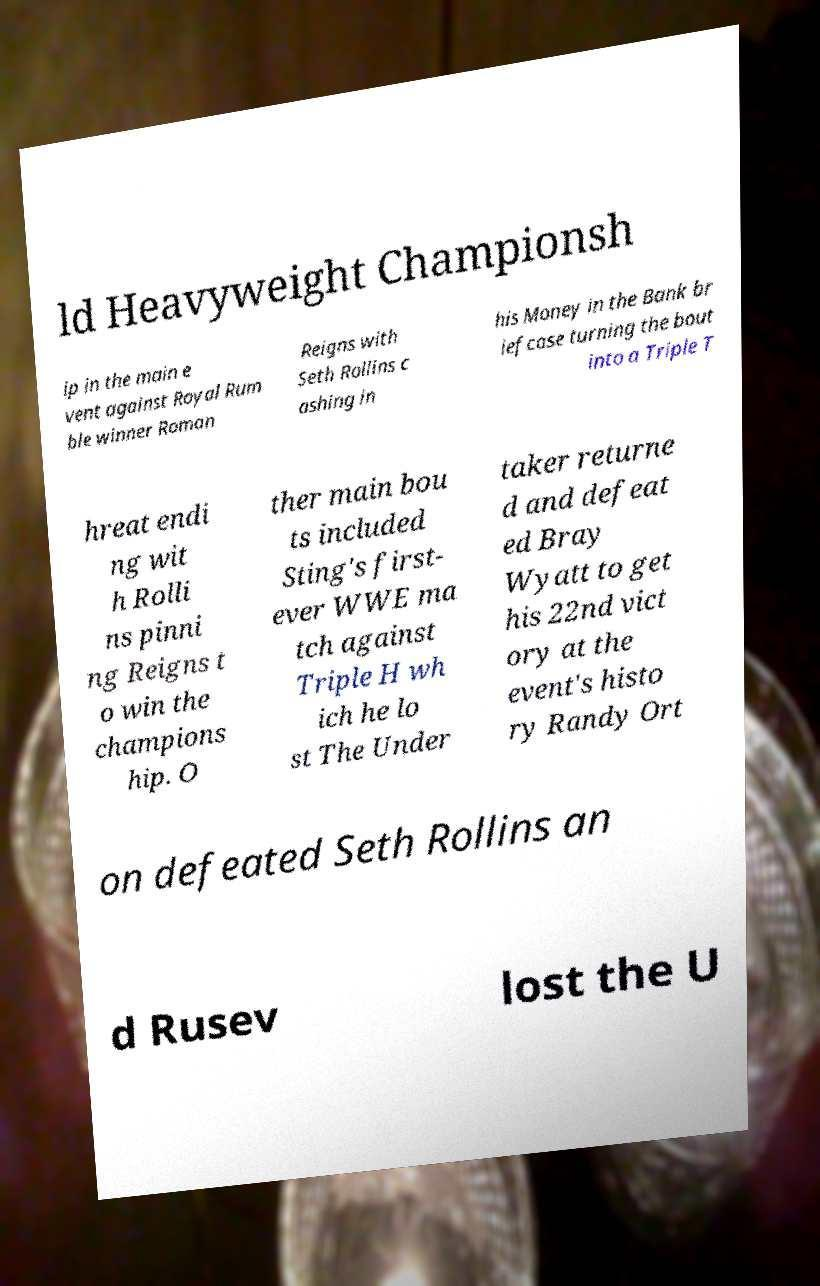What messages or text are displayed in this image? I need them in a readable, typed format. ld Heavyweight Championsh ip in the main e vent against Royal Rum ble winner Roman Reigns with Seth Rollins c ashing in his Money in the Bank br iefcase turning the bout into a Triple T hreat endi ng wit h Rolli ns pinni ng Reigns t o win the champions hip. O ther main bou ts included Sting's first- ever WWE ma tch against Triple H wh ich he lo st The Under taker returne d and defeat ed Bray Wyatt to get his 22nd vict ory at the event's histo ry Randy Ort on defeated Seth Rollins an d Rusev lost the U 